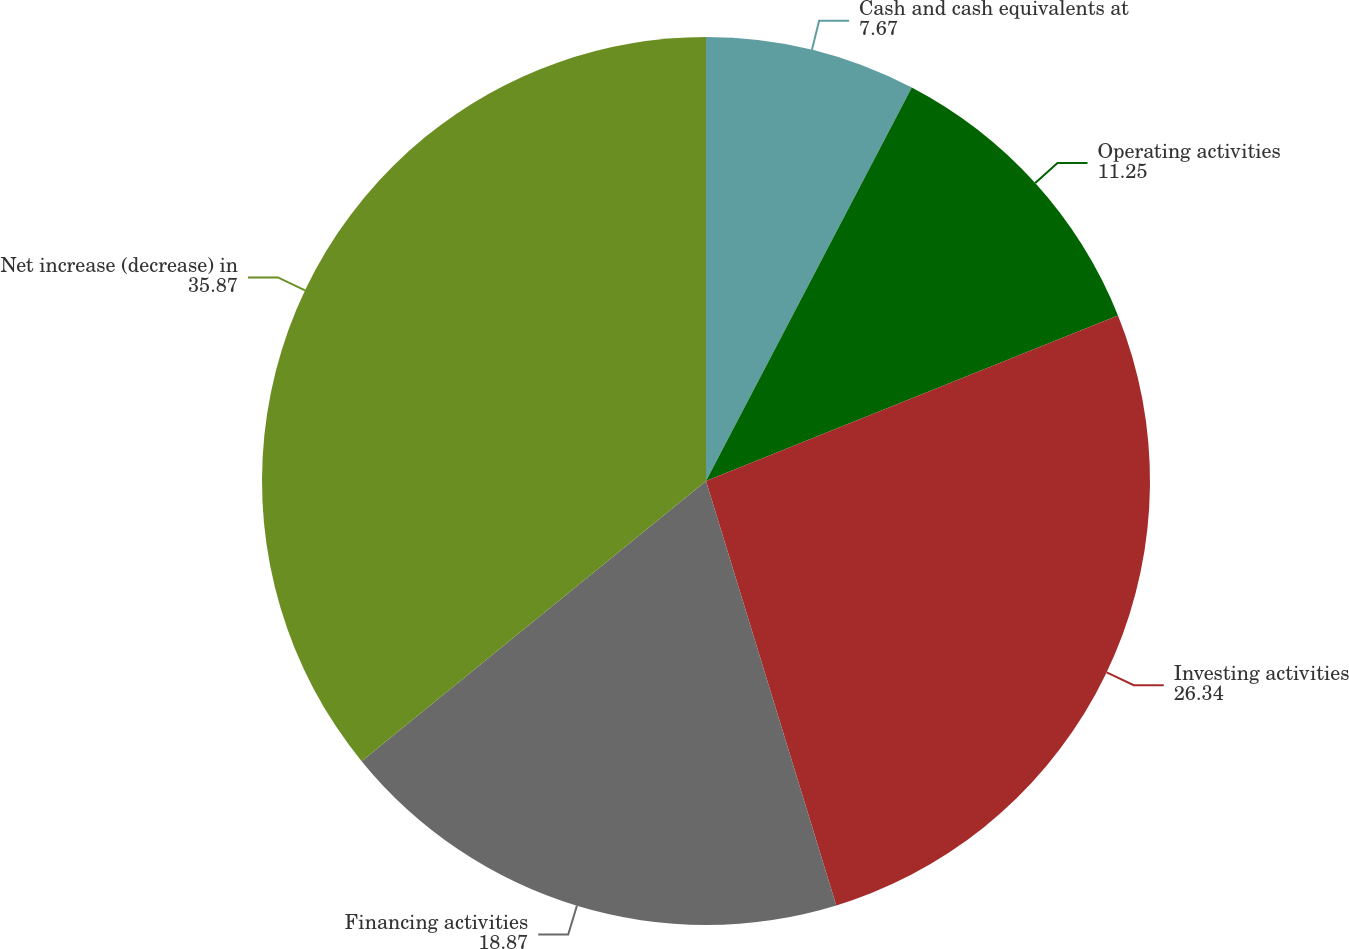<chart> <loc_0><loc_0><loc_500><loc_500><pie_chart><fcel>Cash and cash equivalents at<fcel>Operating activities<fcel>Investing activities<fcel>Financing activities<fcel>Net increase (decrease) in<nl><fcel>7.67%<fcel>11.25%<fcel>26.34%<fcel>18.87%<fcel>35.87%<nl></chart> 